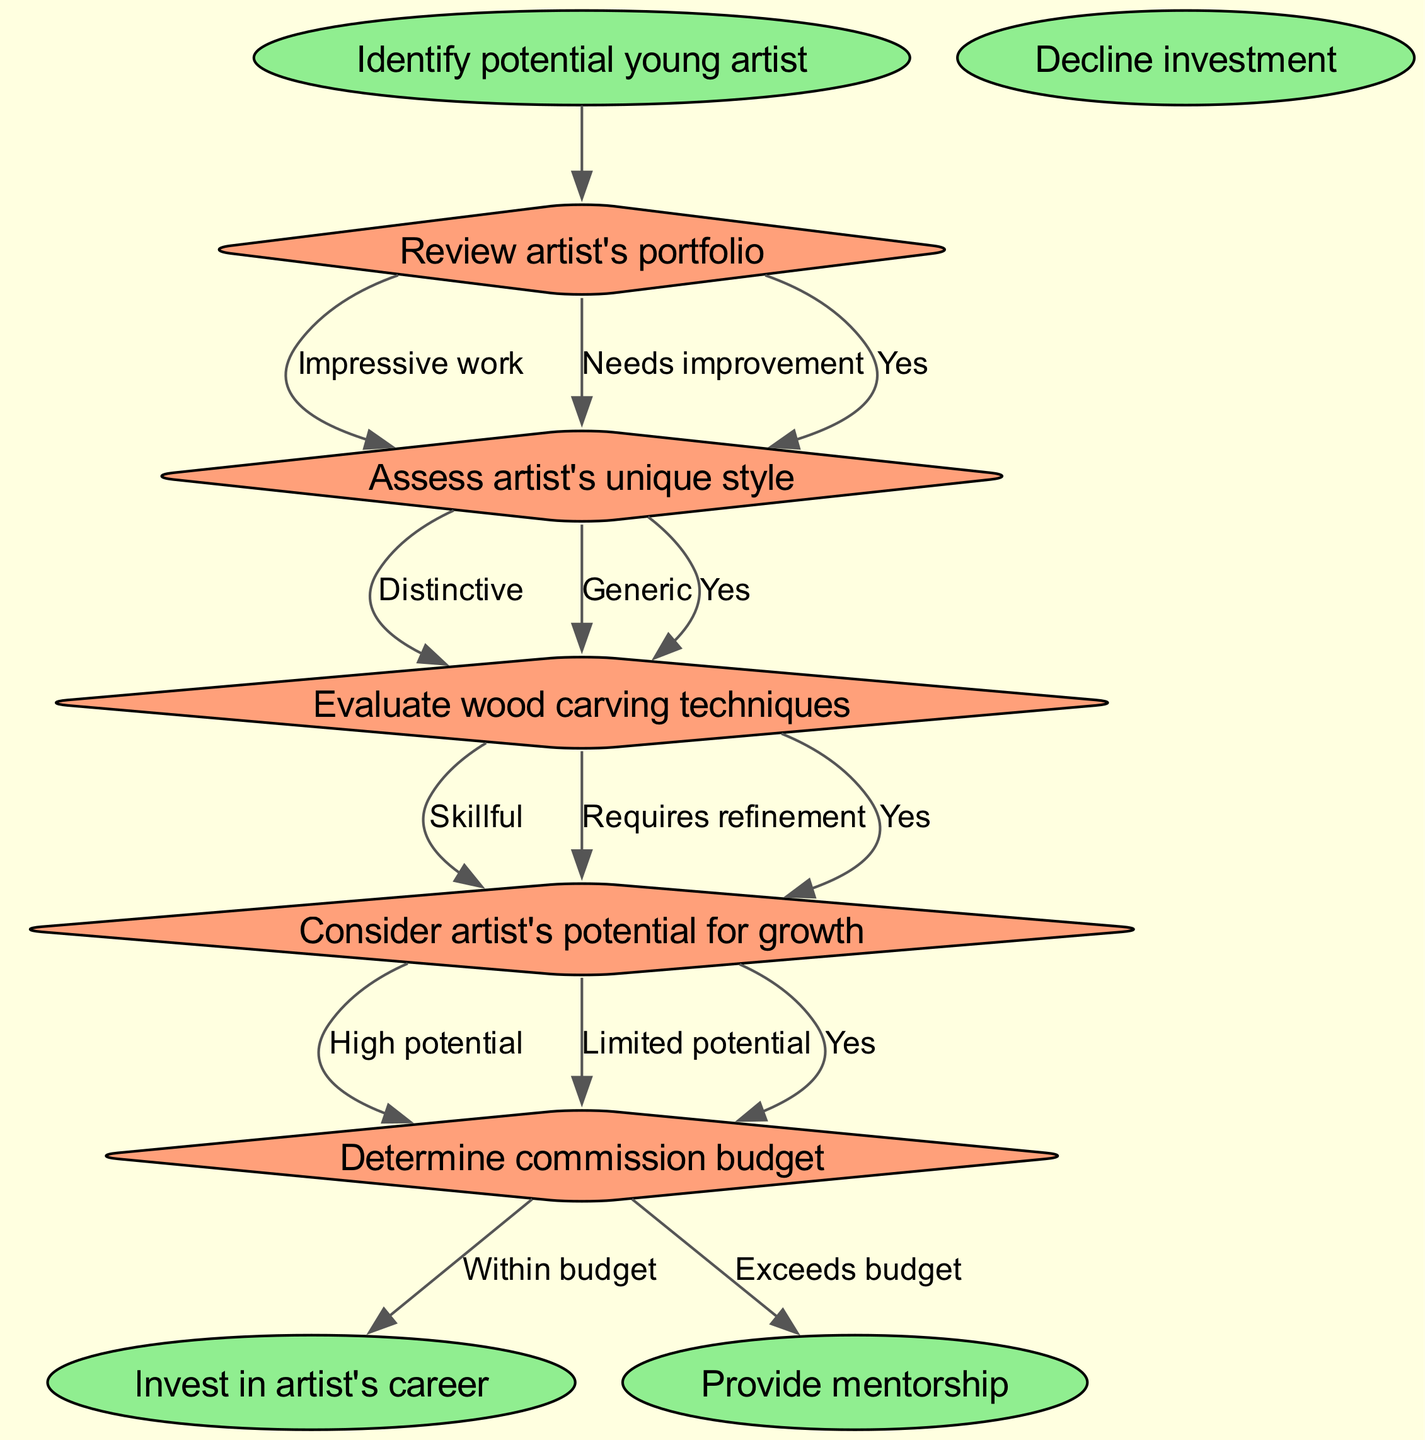What is the first decision node in the flow chart? The first decision node listed in the diagram is to "Review artist's portfolio." This is directly derived from the first element in the "decisions" section of the provided data.
Answer: Review artist's portfolio How many end nodes are there in the flow chart? The end nodes in this flow chart are explicitly mentioned in the "endNodes" section. There are three end nodes: "Invest in artist's career," "Provide mentorship," and "Decline investment." Counting these gives the answer.
Answer: 3 What are the two edges labeled under the decision node "Assess artist's unique style"? The edges that stem from the node "Assess artist's unique style" are "Distinctive" and "Generic." These labels can be found under the specified decision node in the provided data.
Answer: Distinctive, Generic What does a "Yes" edge indicate in this flow chart? The "Yes" edge typically indicates a positive outcome or agreement at a decision point, leading to the next logical step or decision in the flow. This context is derived from the structure of the flow chart where "Yes" leads to subsequent decisions.
Answer: Positive outcome If an artist's portfolio is impressive and their style is distinctive, what is the likely outcome regarding investment? If both the portfolio is impressive and the style is distinctive, this would suggest a positive evaluation leading to continued assessment of the artist's growth potential, ultimately likely resulting in investment. The reasoning follows the arrows and conditions outlined in the flow chart.
Answer: Invest in artist's career What does the decision node "Determine commission budget" lead to if the budget exceeds the allocation? If the decision under "Determine commission budget" indicates that the budget "Exceeds budget," then this node leads to "Decline investment," as it signifies an inability to fund the artist's work based on financial constraints. This is evident from the flow structure back to the associated end node.
Answer: Decline investment What is evaluated after reviewing the artist's portfolio? After the "Review artist's portfolio" decision node, the subsequent node evaluated is "Assess artist's unique style." This connection is directly tied to the flow chart's sequence, reflecting the logic of the decision-making process.
Answer: Assess artist's unique style What potential outcomes can arise from the last decision node regarding growth potential? The last decision node, "Consider artist's potential for growth," can lead to outcomes of either "High potential" or "Limited potential." These are the edges that branch from this decision, indicating the possible paths based on evaluation results.
Answer: High potential, Limited potential 